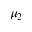<formula> <loc_0><loc_0><loc_500><loc_500>\mu _ { 2 }</formula> 